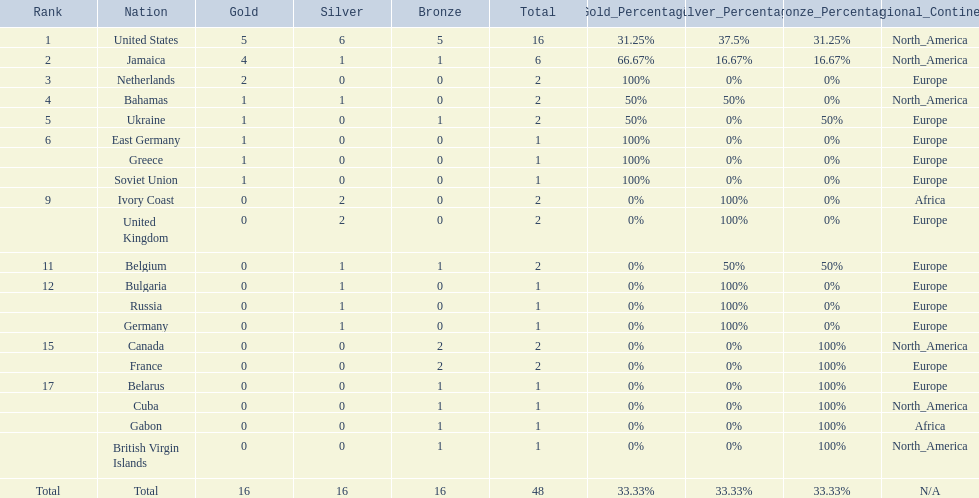Which nations took home at least one gold medal in the 60 metres competition? United States, Jamaica, Netherlands, Bahamas, Ukraine, East Germany, Greece, Soviet Union. Of these nations, which one won the most gold medals? United States. 